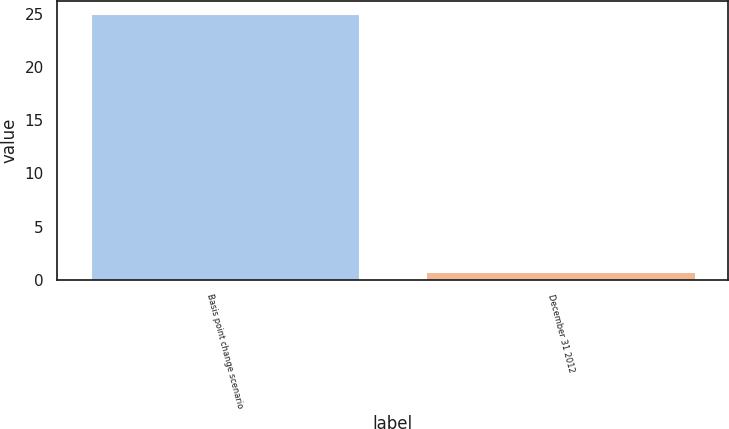<chart> <loc_0><loc_0><loc_500><loc_500><bar_chart><fcel>Basis point change scenario<fcel>December 31 2012<nl><fcel>25<fcel>0.7<nl></chart> 